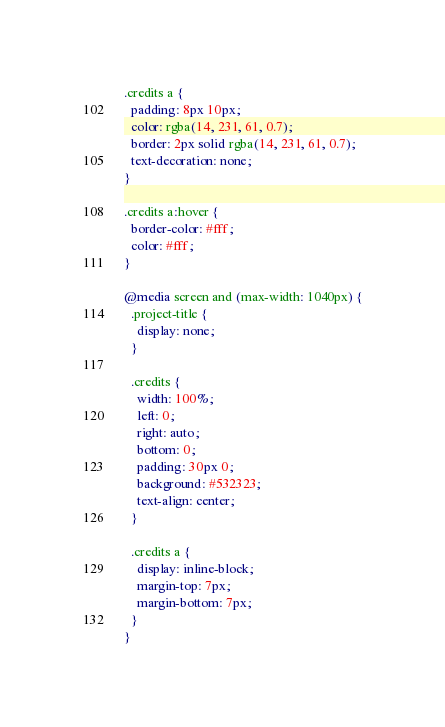<code> <loc_0><loc_0><loc_500><loc_500><_CSS_>
.credits a {
  padding: 8px 10px;
  color: rgba(14, 231, 61, 0.7);
  border: 2px solid rgba(14, 231, 61, 0.7);
  text-decoration: none;
}

.credits a:hover {
  border-color: #fff;
  color: #fff;
}

@media screen and (max-width: 1040px) {
  .project-title {
    display: none;
  }

  .credits {
    width: 100%;
    left: 0;
    right: auto;
    bottom: 0;
    padding: 30px 0;
    background: #532323;
    text-align: center;
  }

  .credits a {
    display: inline-block;
    margin-top: 7px;
    margin-bottom: 7px;
  }
}
</code> 